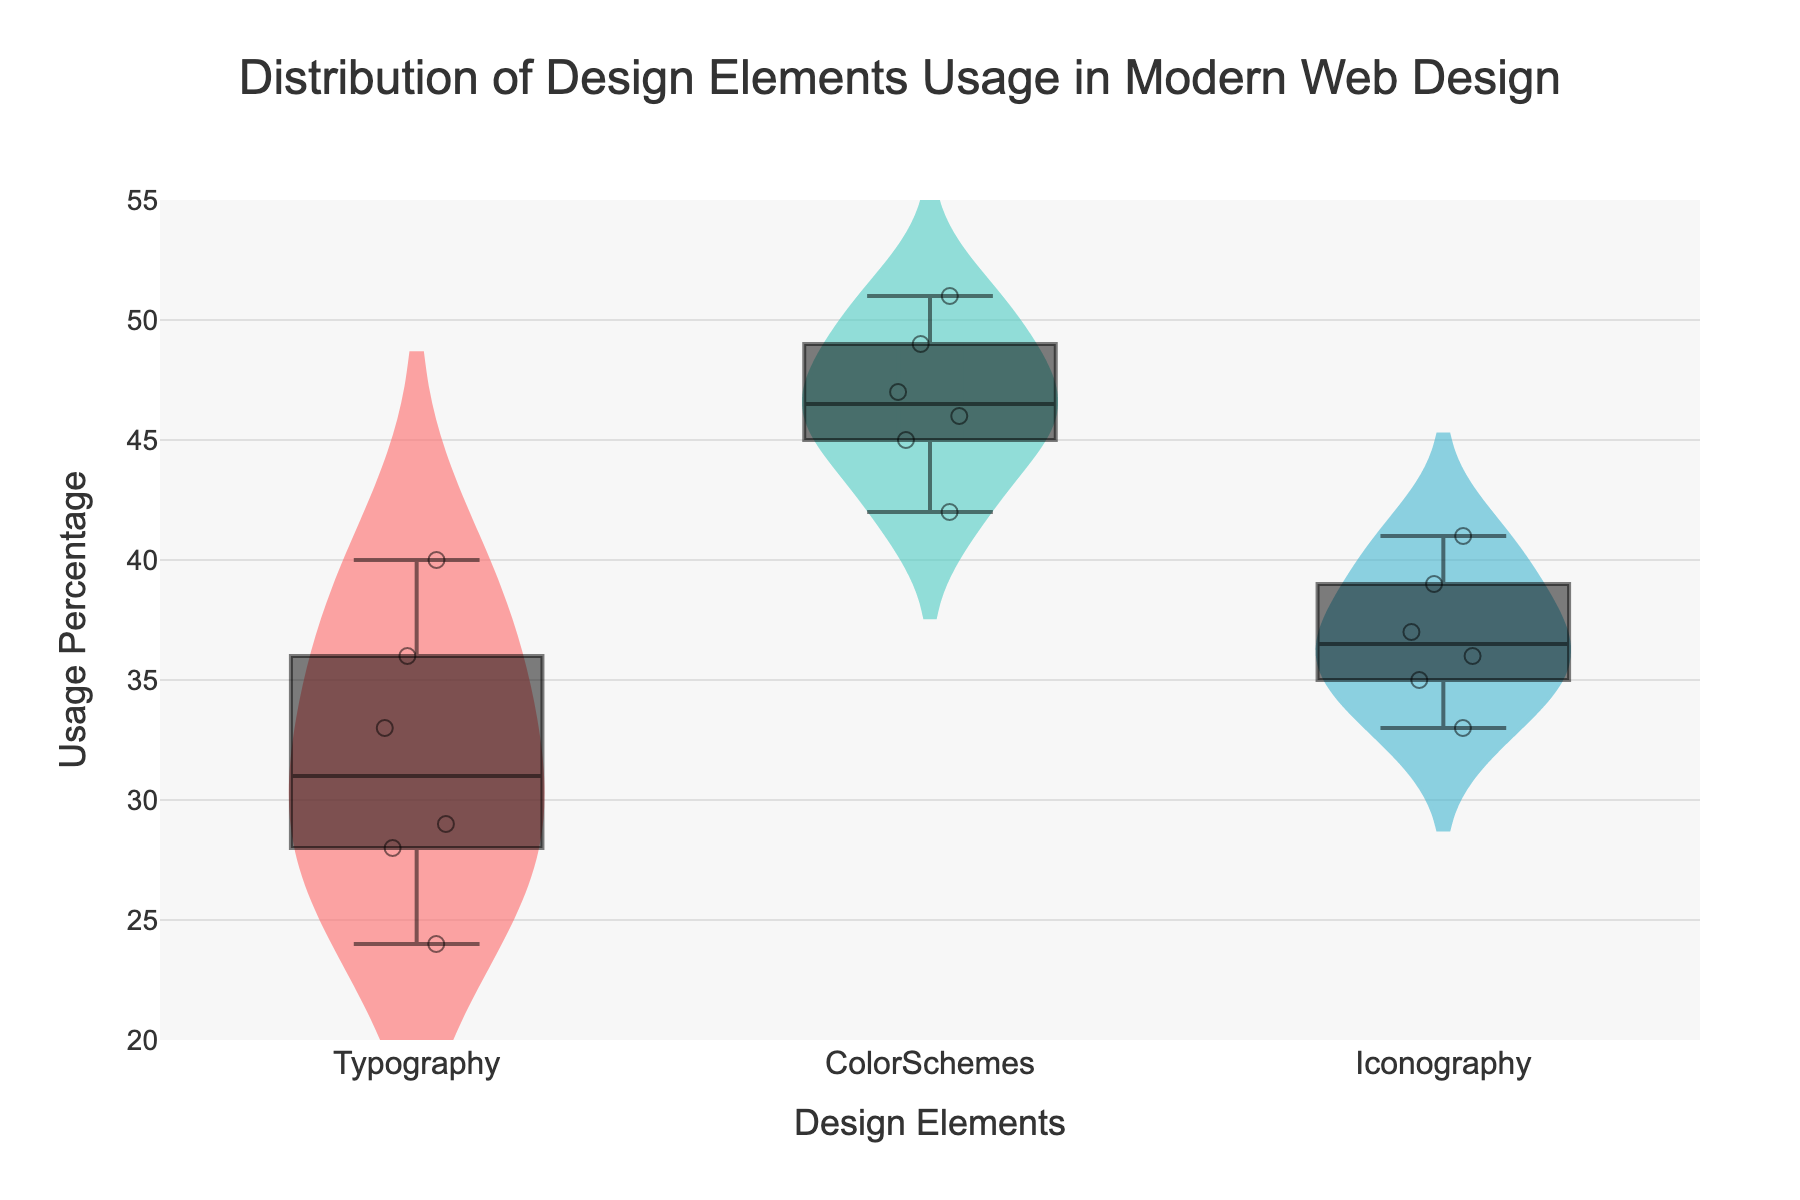How many design elements are analyzed in the chart? The title of the chart indicates the analysis of various design elements, and the presence of three distinct violin plots in different colors suggests that there are three design elements being analyzed.
Answer: 3 Which design element shows the widest distribution of usage percentage? By observing the spread of the violin plots, the one that extends the most across the y-axis represents the widest distribution of usage percentage. The ColorSchemes violin plot spans the widest range on the y-axis.
Answer: ColorSchemes What's the median value of "Typography"? The box plot overlay shows the median as the middle line inside the box. For Typography, locate this central line and read its value.
Answer: 32 Between Typography and Iconography, which one has a higher mean usage percentage? By looking at the mean lines within the violin plots (the dotted horizontal lines), compare the mean lines of Typography and Iconography. Typography's mean line is higher on the y-axis than Iconography’s.
Answer: Typography What is the range of usage percentages for ColorSchemes? The range is determined by the difference between the maximum and minimum values observed in the plot. For ColorSchemes, the violin plot extends from 42 to 51.
Answer: 42 to 51 Which design element has the smallest median usage percentage? By examining the box plots, identify the central horizontal line in the box for each design element. Compare these median lines, and those for Typography and Iconography, Iconography has the smallest median.
Answer: Iconography How does the distribution of usage for Iconography compare to Typography? By analyzing the shape and spread of the violin plots, Iconography has a narrower distribution with most points clustered closer to the median, whereas Typography is more spread out.
Answer: Narrower distribution for Iconography What might be an outlier for Typography usage? Outliers are typically represented by individual points that are separated from the rest of the data. In Typography, a point around 40 seems distinctly higher than the rest of its data points.
Answer: 40 What is the average (mean) usage percentage of Typography? Determine the mean line indicated within the Typography violin plot and read its value, represented by a dotted line around 31.
Answer: 31 